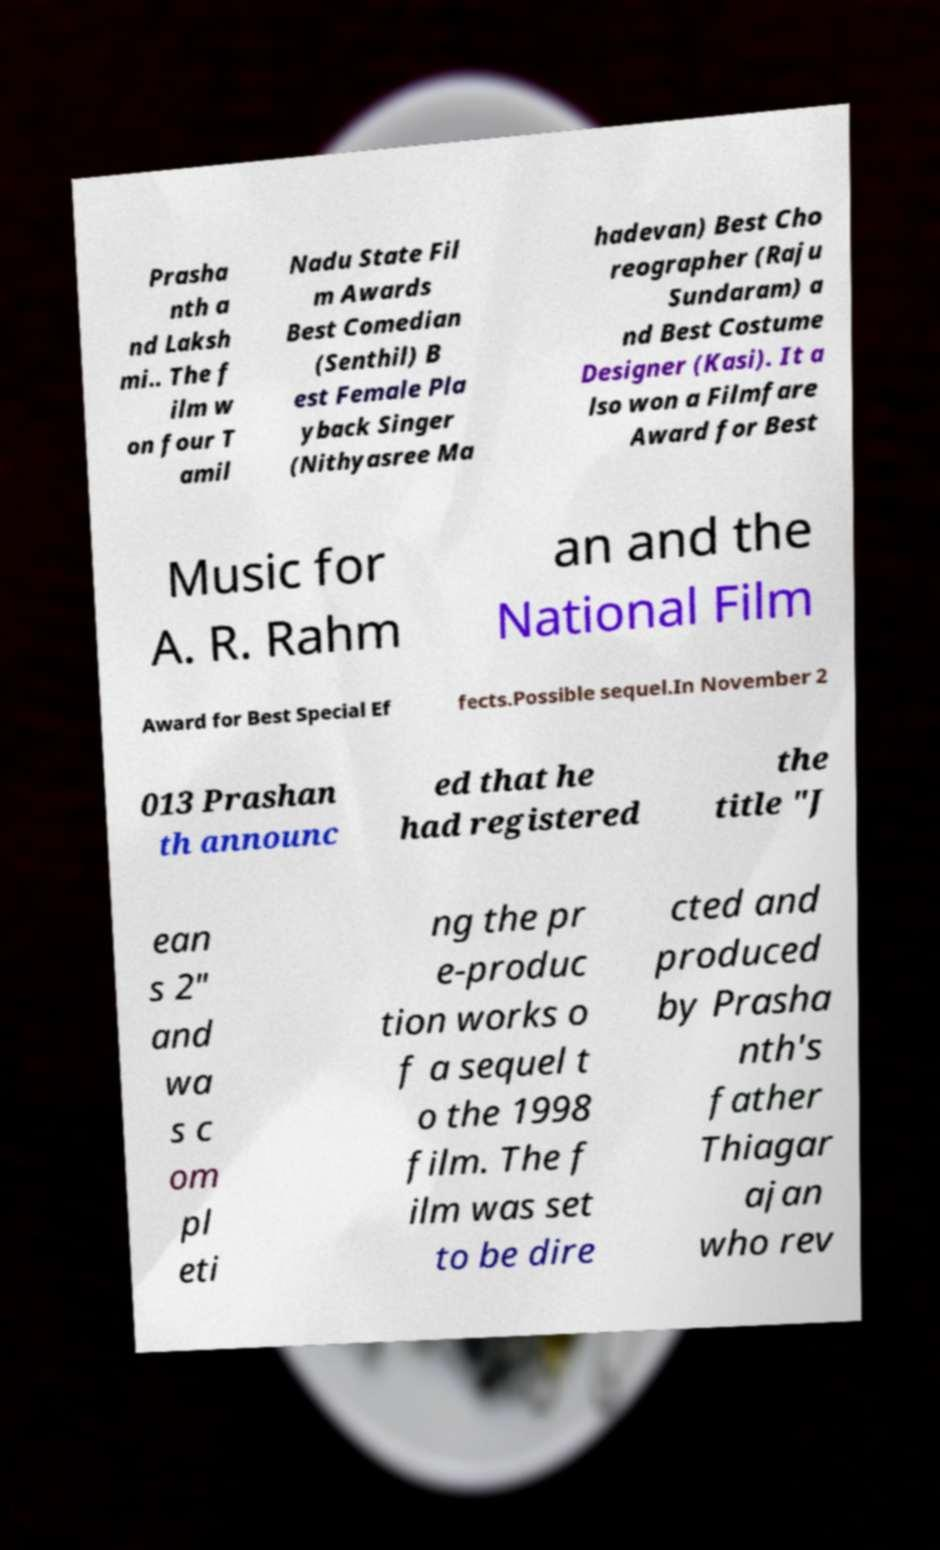Please read and relay the text visible in this image. What does it say? Prasha nth a nd Laksh mi.. The f ilm w on four T amil Nadu State Fil m Awards Best Comedian (Senthil) B est Female Pla yback Singer (Nithyasree Ma hadevan) Best Cho reographer (Raju Sundaram) a nd Best Costume Designer (Kasi). It a lso won a Filmfare Award for Best Music for A. R. Rahm an and the National Film Award for Best Special Ef fects.Possible sequel.In November 2 013 Prashan th announc ed that he had registered the title "J ean s 2" and wa s c om pl eti ng the pr e-produc tion works o f a sequel t o the 1998 film. The f ilm was set to be dire cted and produced by Prasha nth's father Thiagar ajan who rev 